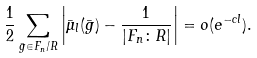<formula> <loc_0><loc_0><loc_500><loc_500>\frac { 1 } { 2 } \sum _ { \bar { g } \in F _ { n } / R } \left | \bar { \mu } _ { l } ( \bar { g } ) - \frac { 1 } { | F _ { n } \colon R | } \right | = o ( e ^ { - c l } ) .</formula> 